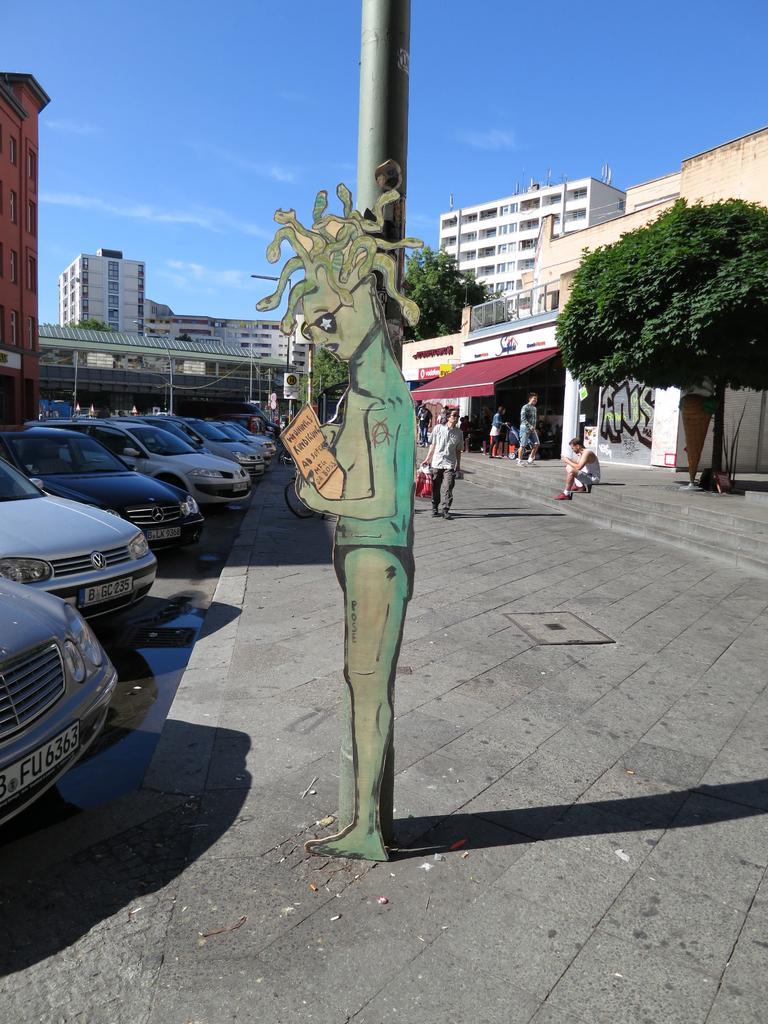Please provide a concise description of this image. In the image there is a pole and in front of the pole there is a poster in the shape of human, around the pole there is a payment and on the left side there are a lot of cars. In the background there are buildings and few people, on the right side there is a tree. 